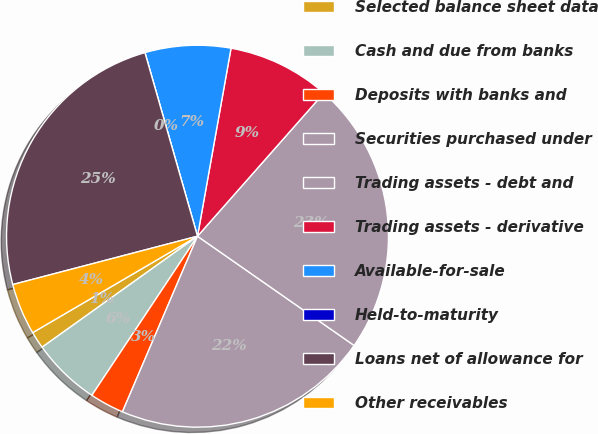Convert chart. <chart><loc_0><loc_0><loc_500><loc_500><pie_chart><fcel>Selected balance sheet data<fcel>Cash and due from banks<fcel>Deposits with banks and<fcel>Securities purchased under<fcel>Trading assets - debt and<fcel>Trading assets - derivative<fcel>Available-for-sale<fcel>Held-to-maturity<fcel>Loans net of allowance for<fcel>Other receivables<nl><fcel>1.45%<fcel>5.8%<fcel>2.9%<fcel>21.74%<fcel>23.19%<fcel>8.7%<fcel>7.25%<fcel>0.0%<fcel>24.64%<fcel>4.35%<nl></chart> 